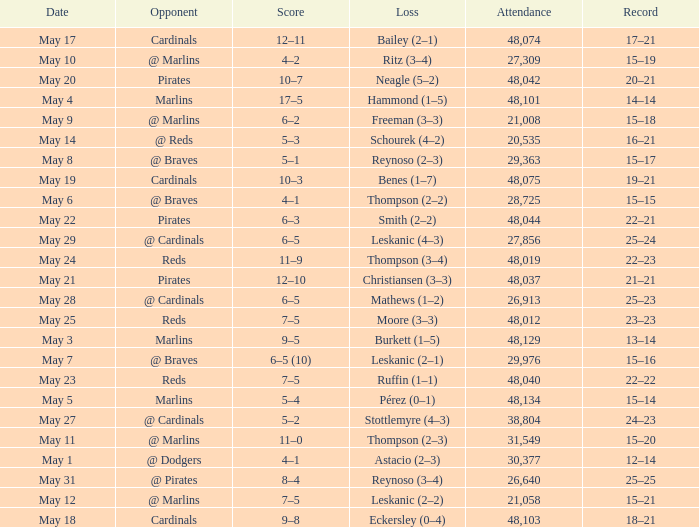Who did the Rockies play at the game that had a score of 6–5 (10)? @ Braves. 